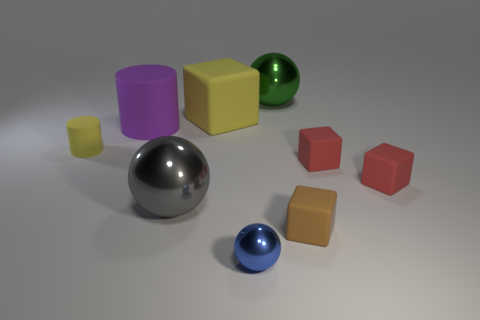Subtract all small matte cubes. How many cubes are left? 1 Subtract 2 cubes. How many cubes are left? 2 Subtract all blocks. How many objects are left? 5 Subtract all purple cylinders. How many cylinders are left? 1 Subtract all brown cylinders. Subtract all blue blocks. How many cylinders are left? 2 Subtract all purple cylinders. How many red cubes are left? 2 Subtract all small blue shiny things. Subtract all large metallic spheres. How many objects are left? 6 Add 8 blue metallic balls. How many blue metallic balls are left? 9 Add 2 large yellow matte objects. How many large yellow matte objects exist? 3 Subtract 0 gray cylinders. How many objects are left? 9 